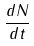<formula> <loc_0><loc_0><loc_500><loc_500>\frac { d N } { d t }</formula> 